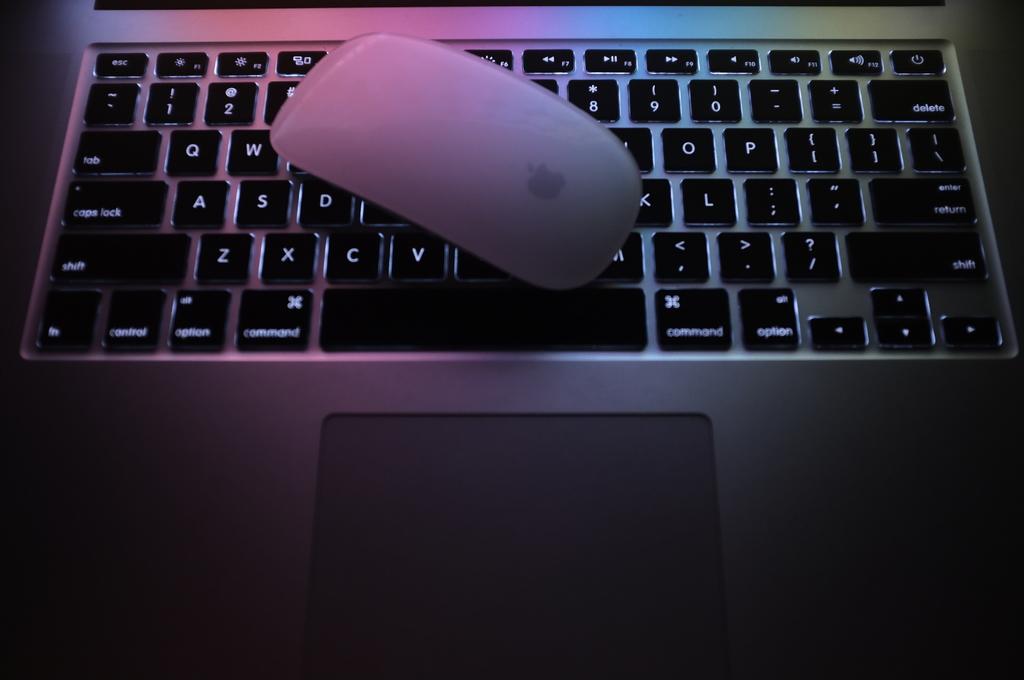What is the longest black button on the right side?
Provide a succinct answer. Shift. Is this a qwerty keyboard?
Your answer should be compact. Yes. 